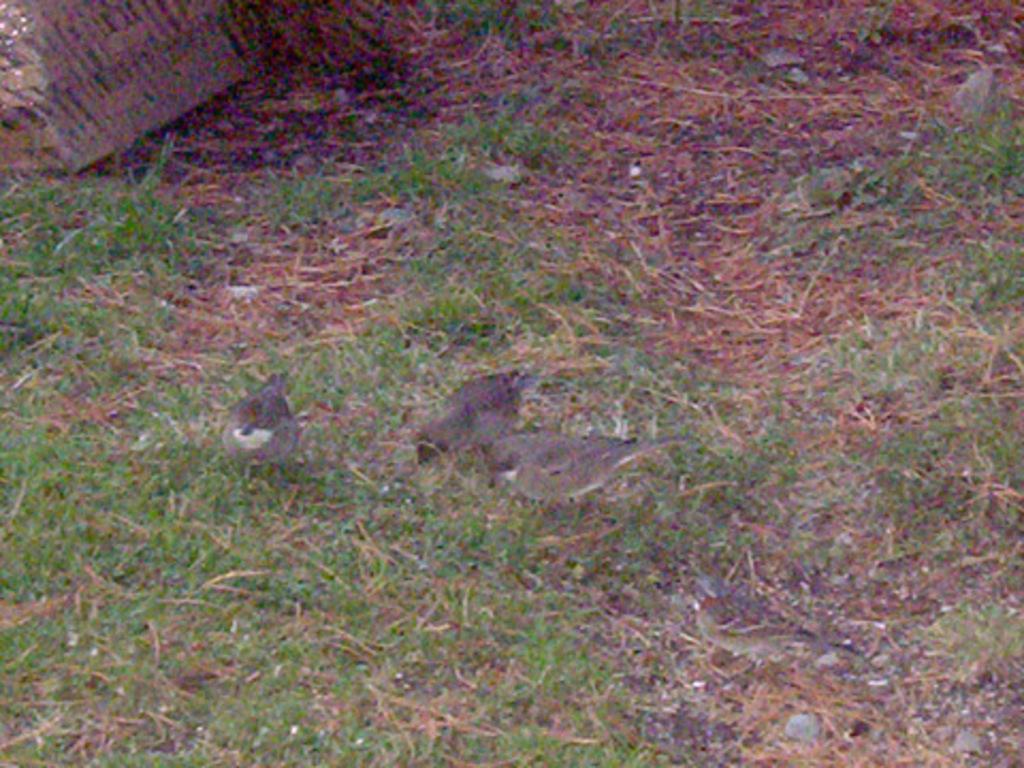Please provide a concise description of this image. In the image we can see birds, grass, dry grass and on the top left we can see an object. 